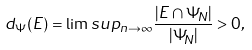<formula> <loc_0><loc_0><loc_500><loc_500>d _ { \Psi } ( E ) = \lim s u p _ { n \to \infty } \frac { | E \cap \Psi _ { N } | } { | \Psi _ { N } | } > 0 ,</formula> 